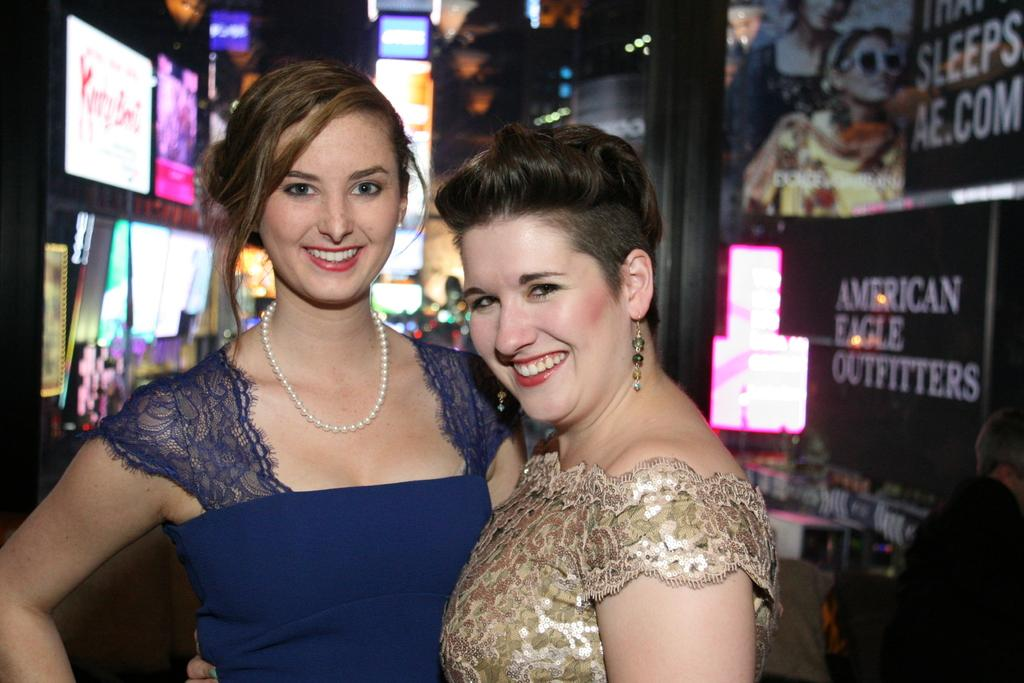Who can be seen in the foreground of the image? There are women in the foreground of the image. What is the facial expression of the women? The women are smiling. What can be seen in the background of the image? There are screens and posters in the background of the image. Where is the person located in the image? There is a person at the bottom right of the image. What type of nail is being hammered by the zebra in the image? There is no zebra or nail present in the image; it features women in the foreground and screens and posters in the background. 